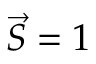Convert formula to latex. <formula><loc_0><loc_0><loc_500><loc_500>{ \vec { S } } = 1</formula> 